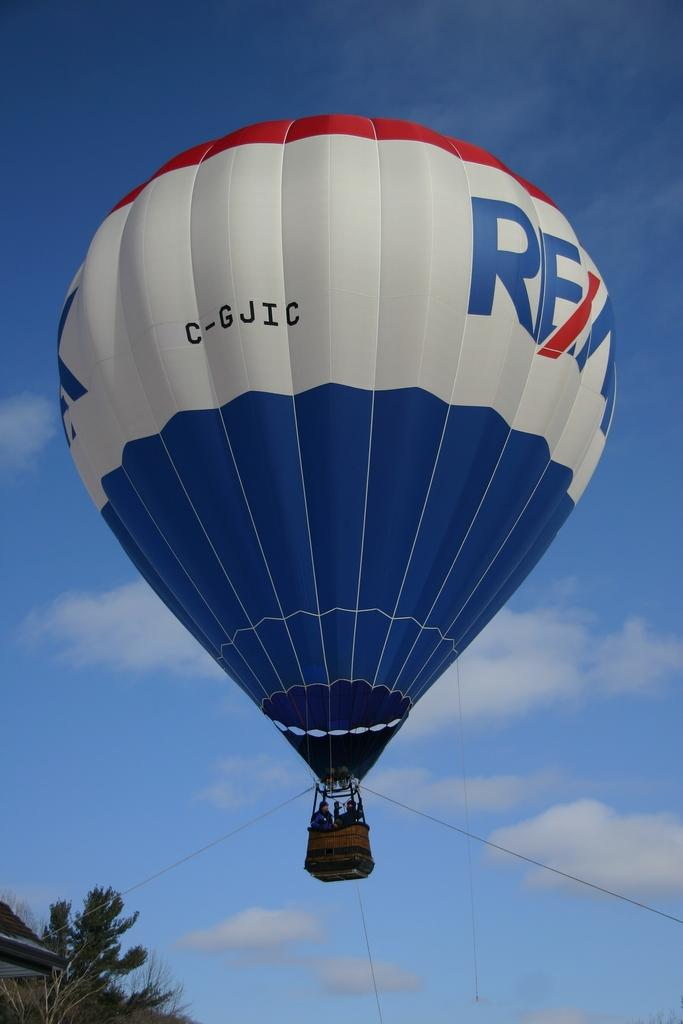What is the main object in the picture? There is a parachute in the picture. What are the people doing inside the parachute? The people are standing inside the parachute. What can be seen in the background of the picture? There are trees visible in the picture. How would you describe the weather based on the image? The sky is clear in the picture, suggesting good weather. What type of leaf is being used as a frame for the parachute in the image? There is no leaf being used as a frame for the parachute in the image. Can you see any yaks in the picture? There are no yaks present in the image. 